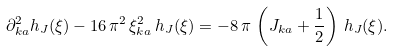<formula> <loc_0><loc_0><loc_500><loc_500>\partial ^ { 2 } _ { k a } h _ { J } ( \xi ) - 1 6 \, \pi ^ { 2 } \, \xi ^ { 2 } _ { k a } \, h _ { J } ( \xi ) = - 8 \, \pi \, \left ( J _ { k a } + \frac { 1 } { 2 } \right ) \, h _ { J } ( \xi ) .</formula> 